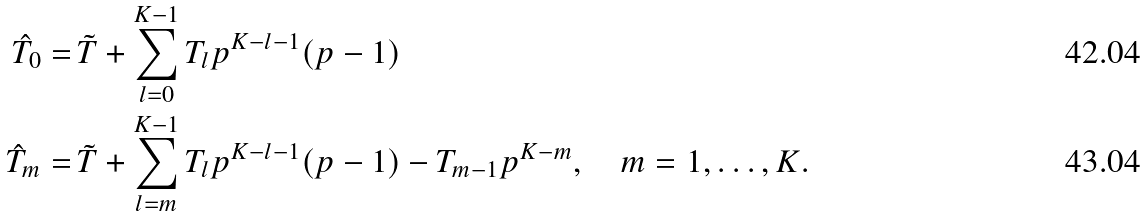<formula> <loc_0><loc_0><loc_500><loc_500>\hat { T } _ { 0 } = & \, \tilde { T } + \sum _ { l = 0 } ^ { K - 1 } T _ { l } p ^ { K - l - 1 } ( p - 1 ) \\ \hat { T } _ { m } = & \, \tilde { T } + \sum _ { l = m } ^ { K - 1 } T _ { l } p ^ { K - l - 1 } ( p - 1 ) - T _ { m - 1 } p ^ { K - m } , \quad m = 1 , \dots , K .</formula> 